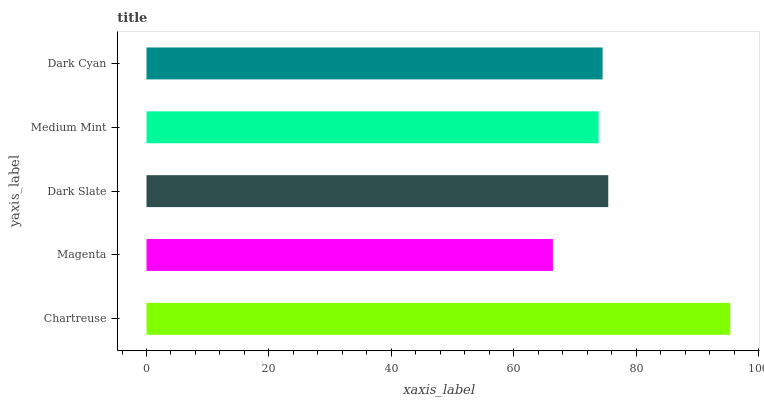Is Magenta the minimum?
Answer yes or no. Yes. Is Chartreuse the maximum?
Answer yes or no. Yes. Is Dark Slate the minimum?
Answer yes or no. No. Is Dark Slate the maximum?
Answer yes or no. No. Is Dark Slate greater than Magenta?
Answer yes or no. Yes. Is Magenta less than Dark Slate?
Answer yes or no. Yes. Is Magenta greater than Dark Slate?
Answer yes or no. No. Is Dark Slate less than Magenta?
Answer yes or no. No. Is Dark Cyan the high median?
Answer yes or no. Yes. Is Dark Cyan the low median?
Answer yes or no. Yes. Is Chartreuse the high median?
Answer yes or no. No. Is Chartreuse the low median?
Answer yes or no. No. 